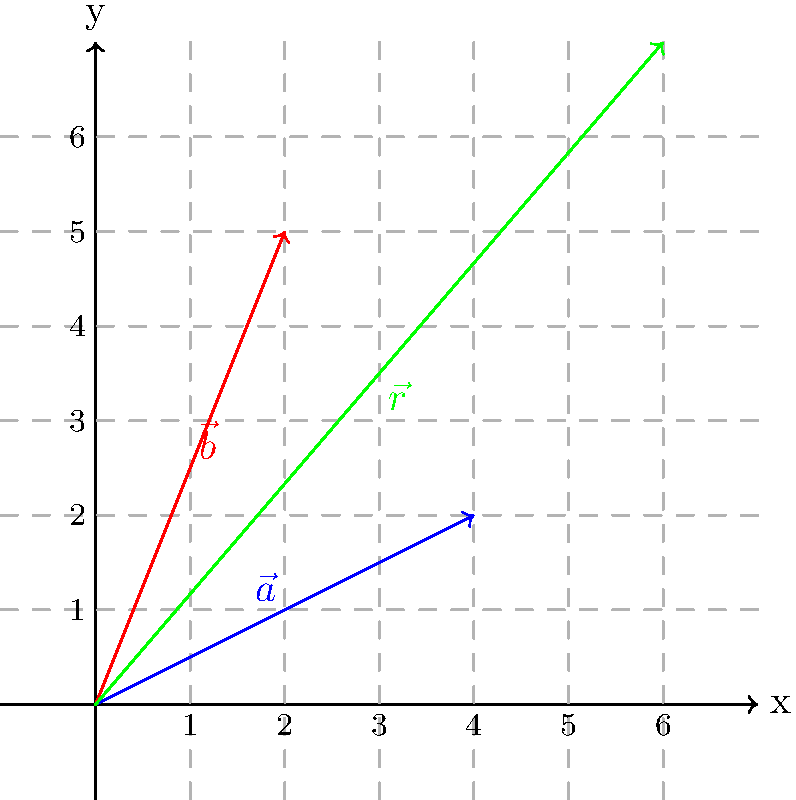In the coordinate plane above, vector $\vec{a}$ (blue) represents the number of books donated to your classroom, and vector $\vec{b}$ (red) represents the number of school supplies donated. If each unit on the x-axis represents 10 items and each unit on the y-axis represents 5 items, what is the total number of items donated, represented by the resultant vector $\vec{r}$ (green)? To find the total number of items donated, we need to:

1. Determine the components of vector $\vec{r}$:
   $\vec{r} = \vec{a} + \vec{b} = (4,2) + (2,5) = (6,7)$

2. Convert the x-component to items:
   x-component = 6 units × 10 items/unit = 60 items

3. Convert the y-component to items:
   y-component = 7 units × 5 items/unit = 35 items

4. Sum the total items:
   Total items = x-component + y-component = 60 + 35 = 95 items

The resultant vector $\vec{r}$ represents the total donation of 95 items.
Answer: 95 items 